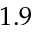Convert formula to latex. <formula><loc_0><loc_0><loc_500><loc_500>1 . 9</formula> 